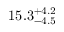Convert formula to latex. <formula><loc_0><loc_0><loc_500><loc_500>1 5 . 3 _ { - 4 . 5 } ^ { + 4 . 2 }</formula> 